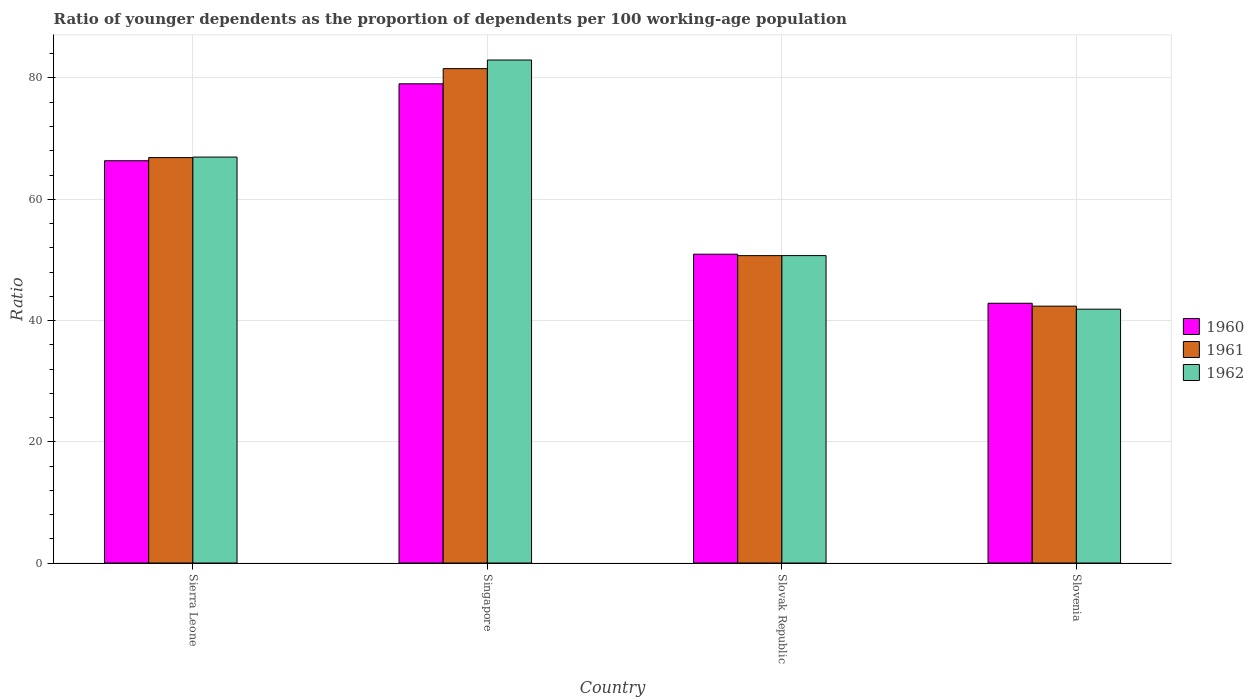How many groups of bars are there?
Keep it short and to the point. 4. Are the number of bars per tick equal to the number of legend labels?
Make the answer very short. Yes. How many bars are there on the 1st tick from the left?
Your answer should be compact. 3. How many bars are there on the 1st tick from the right?
Make the answer very short. 3. What is the label of the 1st group of bars from the left?
Give a very brief answer. Sierra Leone. What is the age dependency ratio(young) in 1962 in Slovak Republic?
Provide a short and direct response. 50.71. Across all countries, what is the maximum age dependency ratio(young) in 1960?
Provide a succinct answer. 79.04. Across all countries, what is the minimum age dependency ratio(young) in 1960?
Your response must be concise. 42.85. In which country was the age dependency ratio(young) in 1961 maximum?
Keep it short and to the point. Singapore. In which country was the age dependency ratio(young) in 1962 minimum?
Your answer should be very brief. Slovenia. What is the total age dependency ratio(young) in 1961 in the graph?
Give a very brief answer. 241.49. What is the difference between the age dependency ratio(young) in 1960 in Sierra Leone and that in Singapore?
Ensure brevity in your answer.  -12.69. What is the difference between the age dependency ratio(young) in 1961 in Slovak Republic and the age dependency ratio(young) in 1960 in Slovenia?
Provide a short and direct response. 7.86. What is the average age dependency ratio(young) in 1962 per country?
Keep it short and to the point. 60.62. What is the difference between the age dependency ratio(young) of/in 1962 and age dependency ratio(young) of/in 1960 in Singapore?
Make the answer very short. 3.92. In how many countries, is the age dependency ratio(young) in 1960 greater than 76?
Offer a terse response. 1. What is the ratio of the age dependency ratio(young) in 1960 in Singapore to that in Slovak Republic?
Your answer should be very brief. 1.55. Is the age dependency ratio(young) in 1960 in Slovak Republic less than that in Slovenia?
Keep it short and to the point. No. Is the difference between the age dependency ratio(young) in 1962 in Singapore and Slovenia greater than the difference between the age dependency ratio(young) in 1960 in Singapore and Slovenia?
Provide a succinct answer. Yes. What is the difference between the highest and the second highest age dependency ratio(young) in 1962?
Make the answer very short. 32.26. What is the difference between the highest and the lowest age dependency ratio(young) in 1962?
Provide a short and direct response. 41.09. In how many countries, is the age dependency ratio(young) in 1962 greater than the average age dependency ratio(young) in 1962 taken over all countries?
Provide a short and direct response. 2. Is the sum of the age dependency ratio(young) in 1960 in Sierra Leone and Slovak Republic greater than the maximum age dependency ratio(young) in 1961 across all countries?
Keep it short and to the point. Yes. What does the 2nd bar from the left in Slovenia represents?
Give a very brief answer. 1961. What does the 3rd bar from the right in Slovenia represents?
Your answer should be compact. 1960. Is it the case that in every country, the sum of the age dependency ratio(young) in 1961 and age dependency ratio(young) in 1962 is greater than the age dependency ratio(young) in 1960?
Provide a short and direct response. Yes. How many countries are there in the graph?
Your response must be concise. 4. Are the values on the major ticks of Y-axis written in scientific E-notation?
Your response must be concise. No. How many legend labels are there?
Offer a terse response. 3. What is the title of the graph?
Offer a terse response. Ratio of younger dependents as the proportion of dependents per 100 working-age population. Does "2012" appear as one of the legend labels in the graph?
Keep it short and to the point. No. What is the label or title of the X-axis?
Your answer should be compact. Country. What is the label or title of the Y-axis?
Give a very brief answer. Ratio. What is the Ratio of 1960 in Sierra Leone?
Your answer should be very brief. 66.35. What is the Ratio of 1961 in Sierra Leone?
Make the answer very short. 66.87. What is the Ratio in 1962 in Sierra Leone?
Keep it short and to the point. 66.96. What is the Ratio of 1960 in Singapore?
Make the answer very short. 79.04. What is the Ratio of 1961 in Singapore?
Make the answer very short. 81.54. What is the Ratio of 1962 in Singapore?
Keep it short and to the point. 82.96. What is the Ratio in 1960 in Slovak Republic?
Your answer should be compact. 50.94. What is the Ratio in 1961 in Slovak Republic?
Your response must be concise. 50.7. What is the Ratio in 1962 in Slovak Republic?
Provide a succinct answer. 50.71. What is the Ratio in 1960 in Slovenia?
Give a very brief answer. 42.85. What is the Ratio in 1961 in Slovenia?
Your response must be concise. 42.37. What is the Ratio in 1962 in Slovenia?
Make the answer very short. 41.87. Across all countries, what is the maximum Ratio of 1960?
Your answer should be compact. 79.04. Across all countries, what is the maximum Ratio of 1961?
Provide a short and direct response. 81.54. Across all countries, what is the maximum Ratio of 1962?
Your response must be concise. 82.96. Across all countries, what is the minimum Ratio in 1960?
Your answer should be very brief. 42.85. Across all countries, what is the minimum Ratio of 1961?
Ensure brevity in your answer.  42.37. Across all countries, what is the minimum Ratio in 1962?
Provide a short and direct response. 41.87. What is the total Ratio in 1960 in the graph?
Provide a succinct answer. 239.18. What is the total Ratio in 1961 in the graph?
Offer a terse response. 241.49. What is the total Ratio in 1962 in the graph?
Keep it short and to the point. 242.5. What is the difference between the Ratio of 1960 in Sierra Leone and that in Singapore?
Ensure brevity in your answer.  -12.69. What is the difference between the Ratio in 1961 in Sierra Leone and that in Singapore?
Provide a short and direct response. -14.67. What is the difference between the Ratio in 1962 in Sierra Leone and that in Singapore?
Provide a short and direct response. -16.01. What is the difference between the Ratio of 1960 in Sierra Leone and that in Slovak Republic?
Keep it short and to the point. 15.41. What is the difference between the Ratio in 1961 in Sierra Leone and that in Slovak Republic?
Your answer should be very brief. 16.17. What is the difference between the Ratio in 1962 in Sierra Leone and that in Slovak Republic?
Offer a terse response. 16.25. What is the difference between the Ratio of 1960 in Sierra Leone and that in Slovenia?
Offer a terse response. 23.51. What is the difference between the Ratio in 1961 in Sierra Leone and that in Slovenia?
Your answer should be compact. 24.5. What is the difference between the Ratio of 1962 in Sierra Leone and that in Slovenia?
Your answer should be compact. 25.09. What is the difference between the Ratio of 1960 in Singapore and that in Slovak Republic?
Ensure brevity in your answer.  28.1. What is the difference between the Ratio in 1961 in Singapore and that in Slovak Republic?
Your answer should be compact. 30.84. What is the difference between the Ratio in 1962 in Singapore and that in Slovak Republic?
Ensure brevity in your answer.  32.26. What is the difference between the Ratio of 1960 in Singapore and that in Slovenia?
Your response must be concise. 36.2. What is the difference between the Ratio in 1961 in Singapore and that in Slovenia?
Your answer should be compact. 39.17. What is the difference between the Ratio in 1962 in Singapore and that in Slovenia?
Your answer should be very brief. 41.09. What is the difference between the Ratio in 1960 in Slovak Republic and that in Slovenia?
Keep it short and to the point. 8.09. What is the difference between the Ratio of 1961 in Slovak Republic and that in Slovenia?
Ensure brevity in your answer.  8.33. What is the difference between the Ratio in 1962 in Slovak Republic and that in Slovenia?
Provide a short and direct response. 8.84. What is the difference between the Ratio of 1960 in Sierra Leone and the Ratio of 1961 in Singapore?
Your response must be concise. -15.19. What is the difference between the Ratio of 1960 in Sierra Leone and the Ratio of 1962 in Singapore?
Offer a very short reply. -16.61. What is the difference between the Ratio of 1961 in Sierra Leone and the Ratio of 1962 in Singapore?
Ensure brevity in your answer.  -16.09. What is the difference between the Ratio in 1960 in Sierra Leone and the Ratio in 1961 in Slovak Republic?
Your response must be concise. 15.65. What is the difference between the Ratio in 1960 in Sierra Leone and the Ratio in 1962 in Slovak Republic?
Provide a succinct answer. 15.65. What is the difference between the Ratio in 1961 in Sierra Leone and the Ratio in 1962 in Slovak Republic?
Make the answer very short. 16.17. What is the difference between the Ratio of 1960 in Sierra Leone and the Ratio of 1961 in Slovenia?
Keep it short and to the point. 23.98. What is the difference between the Ratio of 1960 in Sierra Leone and the Ratio of 1962 in Slovenia?
Provide a succinct answer. 24.48. What is the difference between the Ratio of 1961 in Sierra Leone and the Ratio of 1962 in Slovenia?
Give a very brief answer. 25. What is the difference between the Ratio of 1960 in Singapore and the Ratio of 1961 in Slovak Republic?
Keep it short and to the point. 28.34. What is the difference between the Ratio in 1960 in Singapore and the Ratio in 1962 in Slovak Republic?
Provide a short and direct response. 28.34. What is the difference between the Ratio of 1961 in Singapore and the Ratio of 1962 in Slovak Republic?
Your response must be concise. 30.84. What is the difference between the Ratio of 1960 in Singapore and the Ratio of 1961 in Slovenia?
Offer a very short reply. 36.67. What is the difference between the Ratio in 1960 in Singapore and the Ratio in 1962 in Slovenia?
Your response must be concise. 37.17. What is the difference between the Ratio in 1961 in Singapore and the Ratio in 1962 in Slovenia?
Offer a very short reply. 39.67. What is the difference between the Ratio of 1960 in Slovak Republic and the Ratio of 1961 in Slovenia?
Your answer should be compact. 8.57. What is the difference between the Ratio of 1960 in Slovak Republic and the Ratio of 1962 in Slovenia?
Your response must be concise. 9.07. What is the difference between the Ratio in 1961 in Slovak Republic and the Ratio in 1962 in Slovenia?
Give a very brief answer. 8.83. What is the average Ratio in 1960 per country?
Your answer should be very brief. 59.8. What is the average Ratio of 1961 per country?
Keep it short and to the point. 60.37. What is the average Ratio of 1962 per country?
Provide a succinct answer. 60.62. What is the difference between the Ratio in 1960 and Ratio in 1961 in Sierra Leone?
Make the answer very short. -0.52. What is the difference between the Ratio of 1960 and Ratio of 1962 in Sierra Leone?
Your response must be concise. -0.61. What is the difference between the Ratio of 1961 and Ratio of 1962 in Sierra Leone?
Your answer should be compact. -0.09. What is the difference between the Ratio in 1960 and Ratio in 1961 in Singapore?
Provide a short and direct response. -2.5. What is the difference between the Ratio in 1960 and Ratio in 1962 in Singapore?
Your answer should be very brief. -3.92. What is the difference between the Ratio of 1961 and Ratio of 1962 in Singapore?
Your answer should be compact. -1.42. What is the difference between the Ratio of 1960 and Ratio of 1961 in Slovak Republic?
Your answer should be very brief. 0.24. What is the difference between the Ratio in 1960 and Ratio in 1962 in Slovak Republic?
Give a very brief answer. 0.23. What is the difference between the Ratio in 1961 and Ratio in 1962 in Slovak Republic?
Make the answer very short. -0.01. What is the difference between the Ratio of 1960 and Ratio of 1961 in Slovenia?
Give a very brief answer. 0.48. What is the difference between the Ratio in 1960 and Ratio in 1962 in Slovenia?
Your response must be concise. 0.98. What is the difference between the Ratio of 1961 and Ratio of 1962 in Slovenia?
Make the answer very short. 0.5. What is the ratio of the Ratio of 1960 in Sierra Leone to that in Singapore?
Give a very brief answer. 0.84. What is the ratio of the Ratio in 1961 in Sierra Leone to that in Singapore?
Make the answer very short. 0.82. What is the ratio of the Ratio of 1962 in Sierra Leone to that in Singapore?
Offer a terse response. 0.81. What is the ratio of the Ratio of 1960 in Sierra Leone to that in Slovak Republic?
Offer a very short reply. 1.3. What is the ratio of the Ratio in 1961 in Sierra Leone to that in Slovak Republic?
Your response must be concise. 1.32. What is the ratio of the Ratio in 1962 in Sierra Leone to that in Slovak Republic?
Offer a terse response. 1.32. What is the ratio of the Ratio in 1960 in Sierra Leone to that in Slovenia?
Give a very brief answer. 1.55. What is the ratio of the Ratio of 1961 in Sierra Leone to that in Slovenia?
Give a very brief answer. 1.58. What is the ratio of the Ratio of 1962 in Sierra Leone to that in Slovenia?
Ensure brevity in your answer.  1.6. What is the ratio of the Ratio in 1960 in Singapore to that in Slovak Republic?
Make the answer very short. 1.55. What is the ratio of the Ratio of 1961 in Singapore to that in Slovak Republic?
Your response must be concise. 1.61. What is the ratio of the Ratio of 1962 in Singapore to that in Slovak Republic?
Keep it short and to the point. 1.64. What is the ratio of the Ratio of 1960 in Singapore to that in Slovenia?
Your response must be concise. 1.84. What is the ratio of the Ratio of 1961 in Singapore to that in Slovenia?
Provide a short and direct response. 1.92. What is the ratio of the Ratio of 1962 in Singapore to that in Slovenia?
Your response must be concise. 1.98. What is the ratio of the Ratio in 1960 in Slovak Republic to that in Slovenia?
Give a very brief answer. 1.19. What is the ratio of the Ratio of 1961 in Slovak Republic to that in Slovenia?
Offer a terse response. 1.2. What is the ratio of the Ratio of 1962 in Slovak Republic to that in Slovenia?
Offer a very short reply. 1.21. What is the difference between the highest and the second highest Ratio in 1960?
Offer a terse response. 12.69. What is the difference between the highest and the second highest Ratio of 1961?
Provide a succinct answer. 14.67. What is the difference between the highest and the second highest Ratio in 1962?
Give a very brief answer. 16.01. What is the difference between the highest and the lowest Ratio in 1960?
Your answer should be very brief. 36.2. What is the difference between the highest and the lowest Ratio of 1961?
Make the answer very short. 39.17. What is the difference between the highest and the lowest Ratio in 1962?
Your response must be concise. 41.09. 